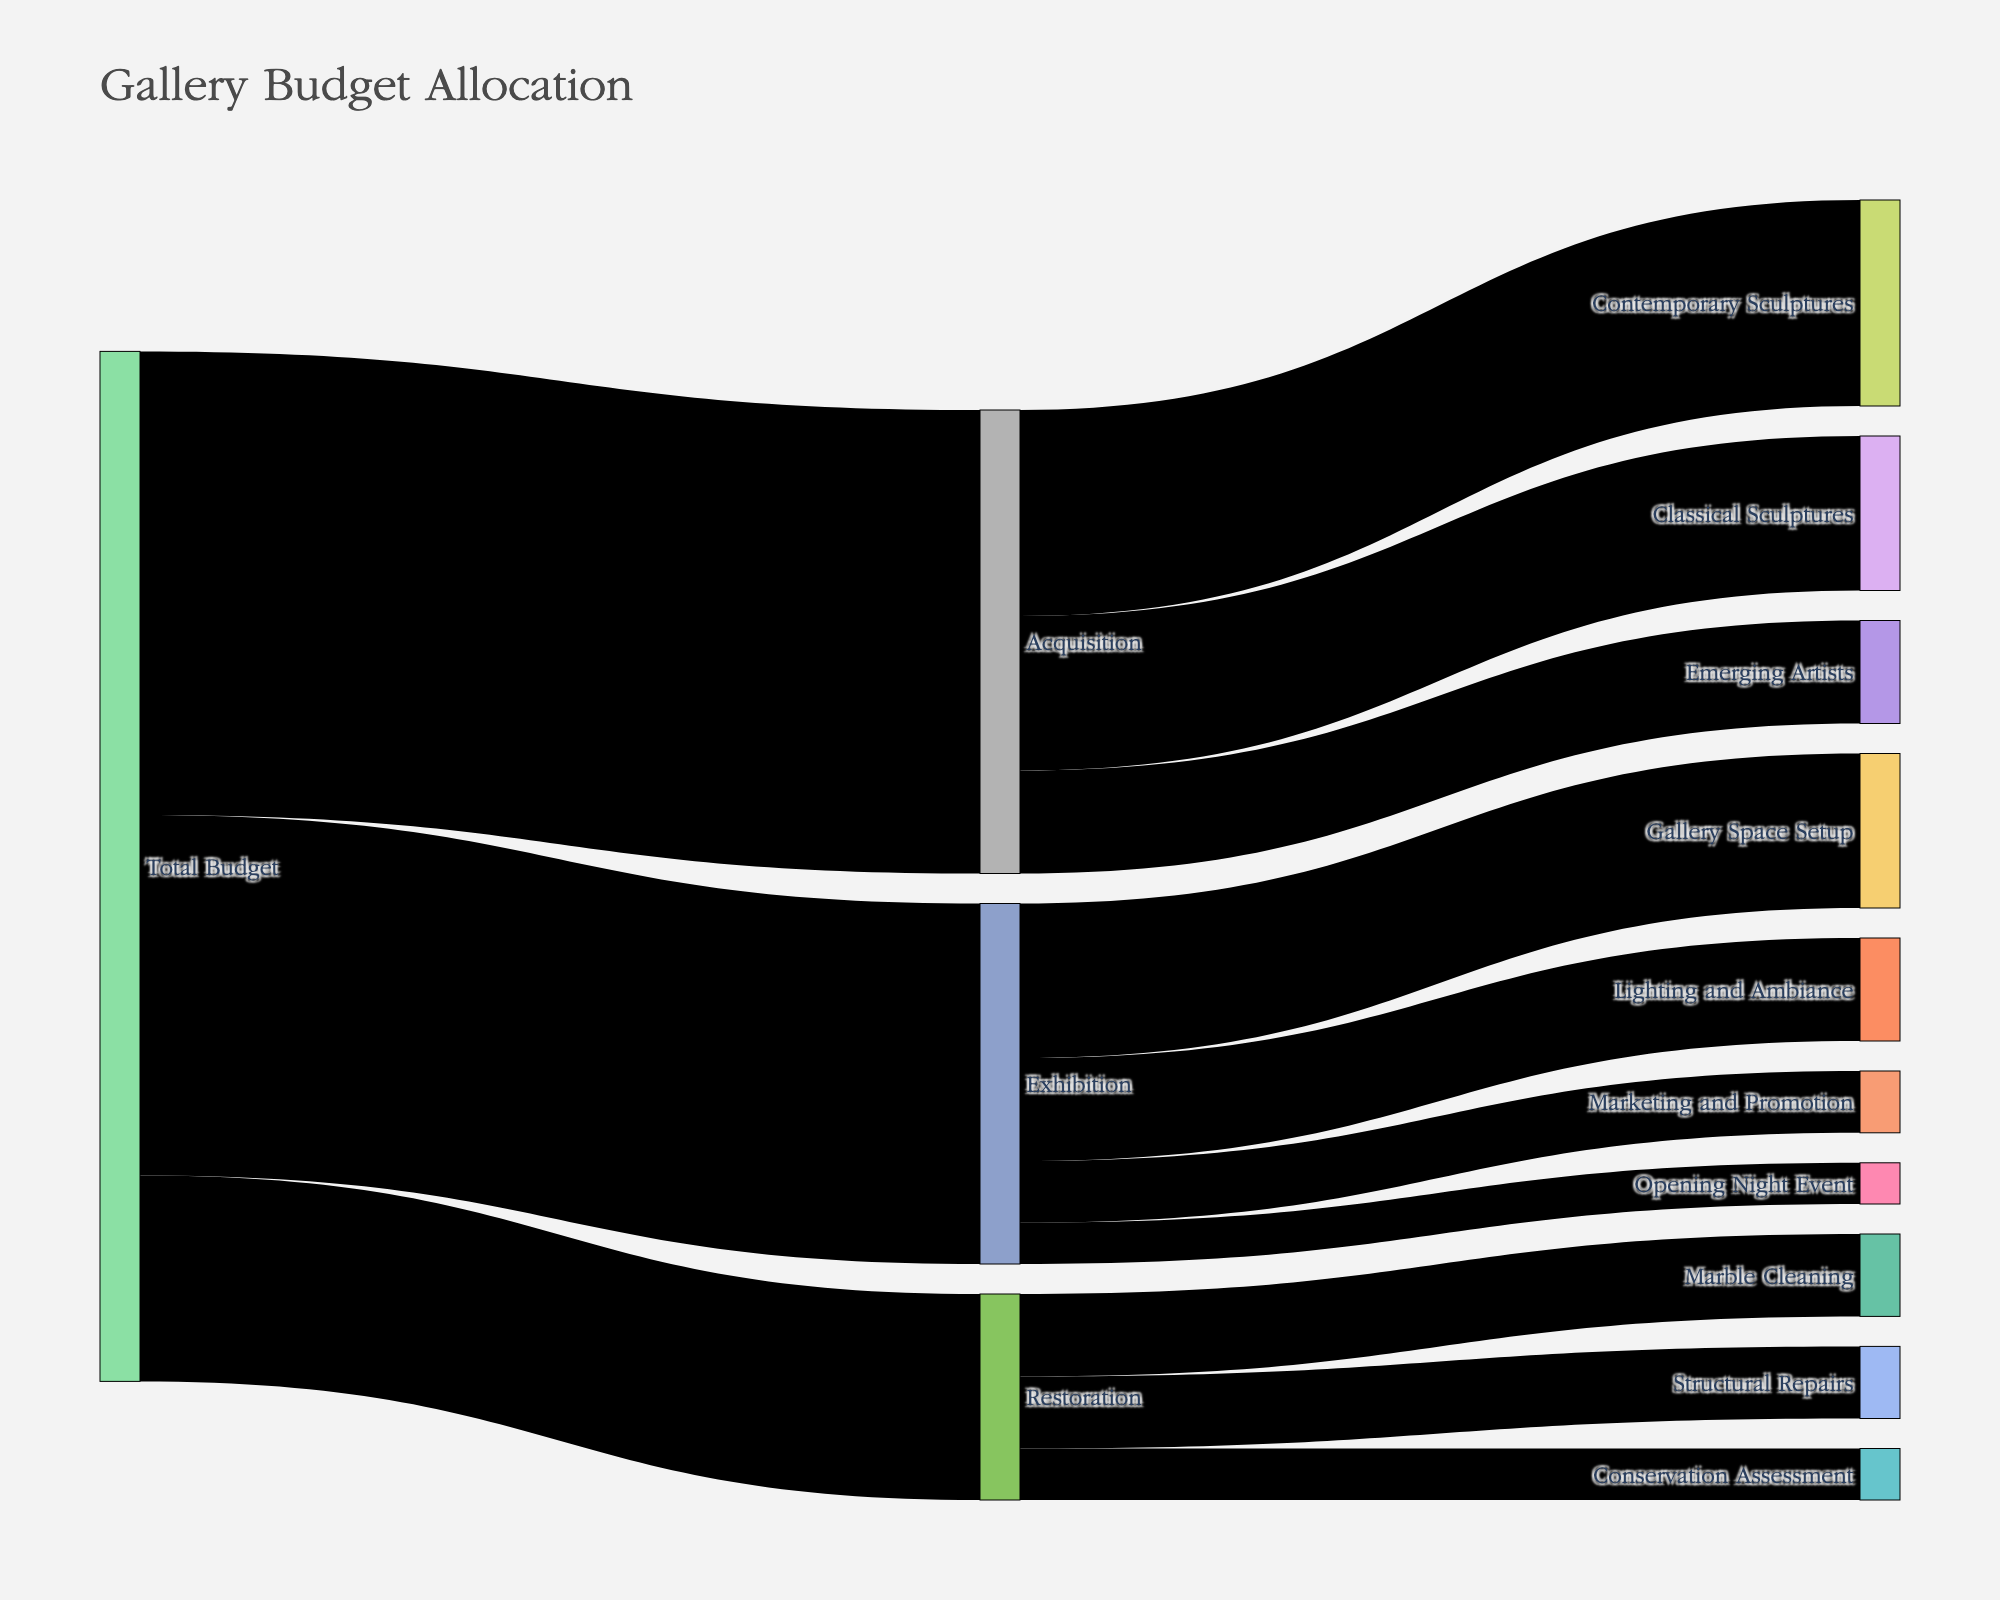How much of the total budget is allocated to Acquisition? Look at the link connecting "Total Budget" to "Acquisition." The value shown is 450,000.
Answer: 450,000 What is the total budget allocated to Restoration? Find the value on the link from "Total Budget" to "Restoration." It is shown as 200,000.
Answer: 200,000 How much of the exhibition cost is being allocated to Gallery Space Setup? Check the link from "Exhibition" to "Gallery Space Setup." The value is 150,000.
Answer: 150,000 What is the combined budget for Contemporary and Classical Sculptures? Sum the values of the links from "Acquisition" to "Contemporary Sculptures" (200,000) and "Classical Sculptures" (150,000). The combined value is 200,000 + 150,000 = 350,000.
Answer: 350,000 Which segment within Restoration receives the least allocation? Compare the values of "Marble Cleaning" (80,000), "Structural Repairs" (70,000), and "Conservation Assessment" (50,000). The smallest value is "Conservation Assessment" with 50,000.
Answer: Conservation Assessment How does the budget for Lighting and Ambiance compare to the budget for Marketing and Promotion? Compare the values from "Exhibition" to "Lighting and Ambiance" (100,000) and "Marketing and Promotion" (60,000). 100,000 is greater than 60,000.
Answer: Lighting and Ambiance What fraction of the Acquisition budget is allocated to Emerging Artists? The Acquisition budget is 450,000, and 100,000 is allocated to Emerging Artists. The fraction is 100,000 / 450,000 = 2/9.
Answer: 2/9 Can you determine the total budget allocated across all categories? Sum the values from "Total Budget" to "Acquisition" (450,000), "Restoration" (200,000), and "Exhibition" (350,000). The total is 450,000 + 200,000 + 350,000 = 1,000,000.
Answer: 1,000,000 Which allocation receives more funding: Structural Repairs or Opening Night Event? Compare the values of "Structural Repairs" (70,000) and "Opening Night Event" (40,000). 70,000 is greater than 40,000.
Answer: Structural Repairs What percentage of the Total Budget is allocated to Exhibition costs? The Total Budget is 1,000,000. The Exhibition costs are 350,000. The percentage is (350,000 / 1,000,000) * 100 = 35%.
Answer: 35% 